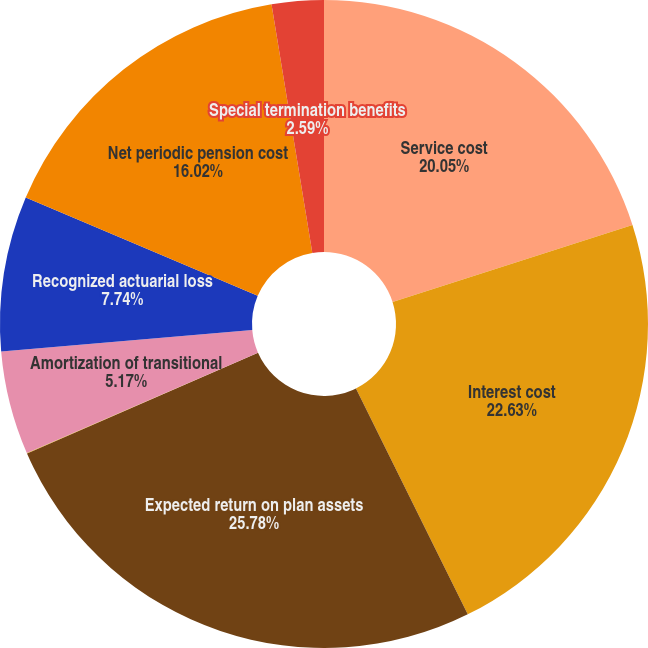Convert chart. <chart><loc_0><loc_0><loc_500><loc_500><pie_chart><fcel>Service cost<fcel>Interest cost<fcel>Expected return on plan assets<fcel>Amortization of prior service<fcel>Amortization of transitional<fcel>Recognized actuarial loss<fcel>Net periodic pension cost<fcel>Special termination benefits<nl><fcel>20.05%<fcel>22.63%<fcel>25.77%<fcel>0.02%<fcel>5.17%<fcel>7.74%<fcel>16.02%<fcel>2.59%<nl></chart> 